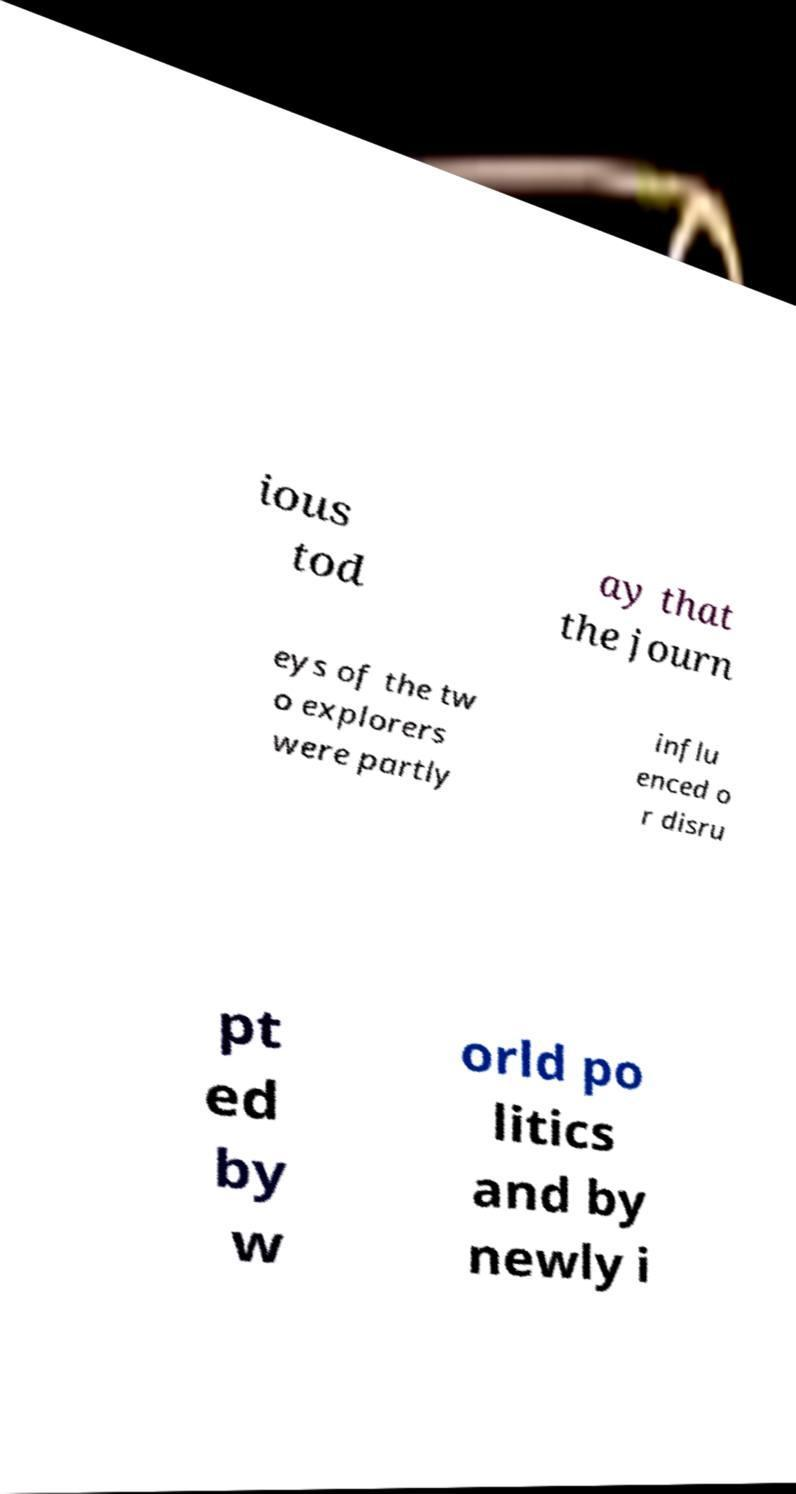Can you read and provide the text displayed in the image?This photo seems to have some interesting text. Can you extract and type it out for me? ious tod ay that the journ eys of the tw o explorers were partly influ enced o r disru pt ed by w orld po litics and by newly i 